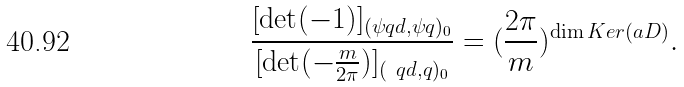<formula> <loc_0><loc_0><loc_500><loc_500>\frac { [ \det ( - 1 ) ] _ { ( \psi q d , \psi q ) _ { 0 } } } { [ \det ( - \frac { m } { 2 \pi } ) ] _ { ( \ q d , q ) _ { 0 } } } = ( \frac { 2 \pi } { m } ) ^ { \dim K e r ( { \sl a D } ) } .</formula> 